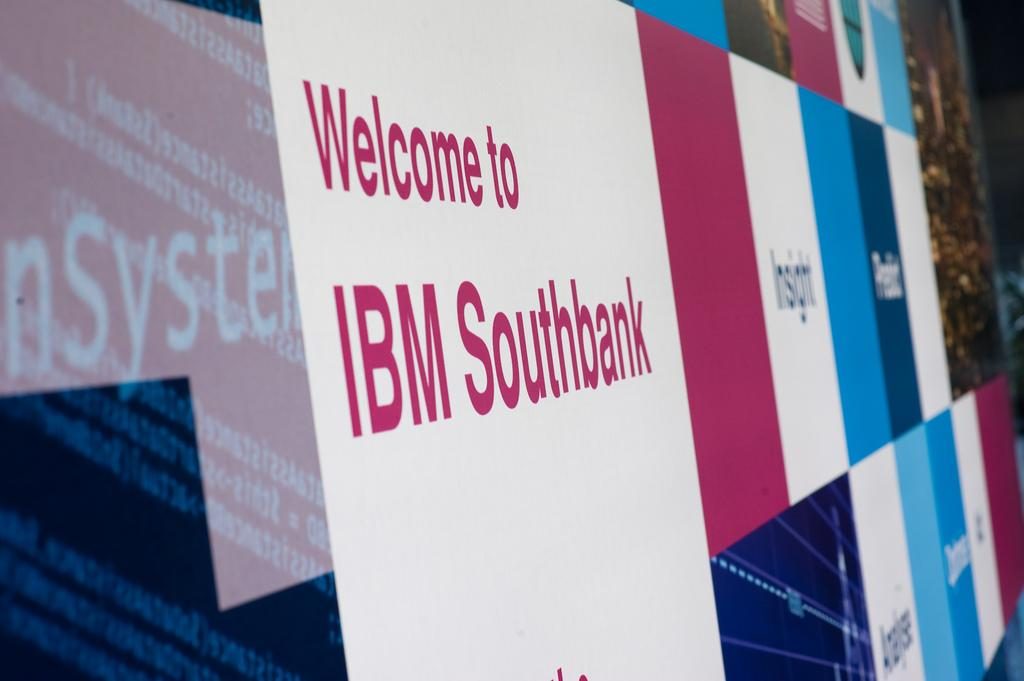Provide a one-sentence caption for the provided image. A purple and blue sign welcomes people to IBM Southbank. 